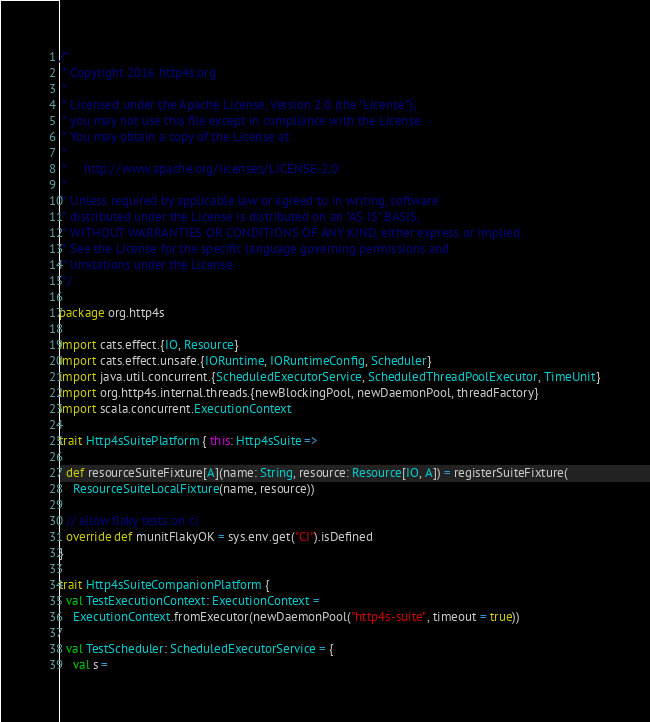Convert code to text. <code><loc_0><loc_0><loc_500><loc_500><_Scala_>/*
 * Copyright 2016 http4s.org
 *
 * Licensed under the Apache License, Version 2.0 (the "License");
 * you may not use this file except in compliance with the License.
 * You may obtain a copy of the License at
 *
 *     http://www.apache.org/licenses/LICENSE-2.0
 *
 * Unless required by applicable law or agreed to in writing, software
 * distributed under the License is distributed on an "AS IS" BASIS,
 * WITHOUT WARRANTIES OR CONDITIONS OF ANY KIND, either express or implied.
 * See the License for the specific language governing permissions and
 * limitations under the License.
 */

package org.http4s

import cats.effect.{IO, Resource}
import cats.effect.unsafe.{IORuntime, IORuntimeConfig, Scheduler}
import java.util.concurrent.{ScheduledExecutorService, ScheduledThreadPoolExecutor, TimeUnit}
import org.http4s.internal.threads.{newBlockingPool, newDaemonPool, threadFactory}
import scala.concurrent.ExecutionContext

trait Http4sSuitePlatform { this: Http4sSuite =>

  def resourceSuiteFixture[A](name: String, resource: Resource[IO, A]) = registerSuiteFixture(
    ResourceSuiteLocalFixture(name, resource))

  // allow flaky tests on ci
  override def munitFlakyOK = sys.env.get("CI").isDefined
}

trait Http4sSuiteCompanionPlatform {
  val TestExecutionContext: ExecutionContext =
    ExecutionContext.fromExecutor(newDaemonPool("http4s-suite", timeout = true))

  val TestScheduler: ScheduledExecutorService = {
    val s =</code> 